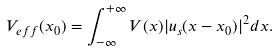<formula> <loc_0><loc_0><loc_500><loc_500>V _ { e f f } ( x _ { 0 } ) = \int _ { - \infty } ^ { + \infty } V ( x ) | u _ { s } ( x - x _ { 0 } ) | ^ { 2 } d x .</formula> 